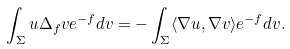Convert formula to latex. <formula><loc_0><loc_0><loc_500><loc_500>\int _ { \Sigma } u \Delta _ { f } v e ^ { - f } d v = - \int _ { \Sigma } \langle \nabla u , \nabla v \rangle e ^ { - f } d v .</formula> 